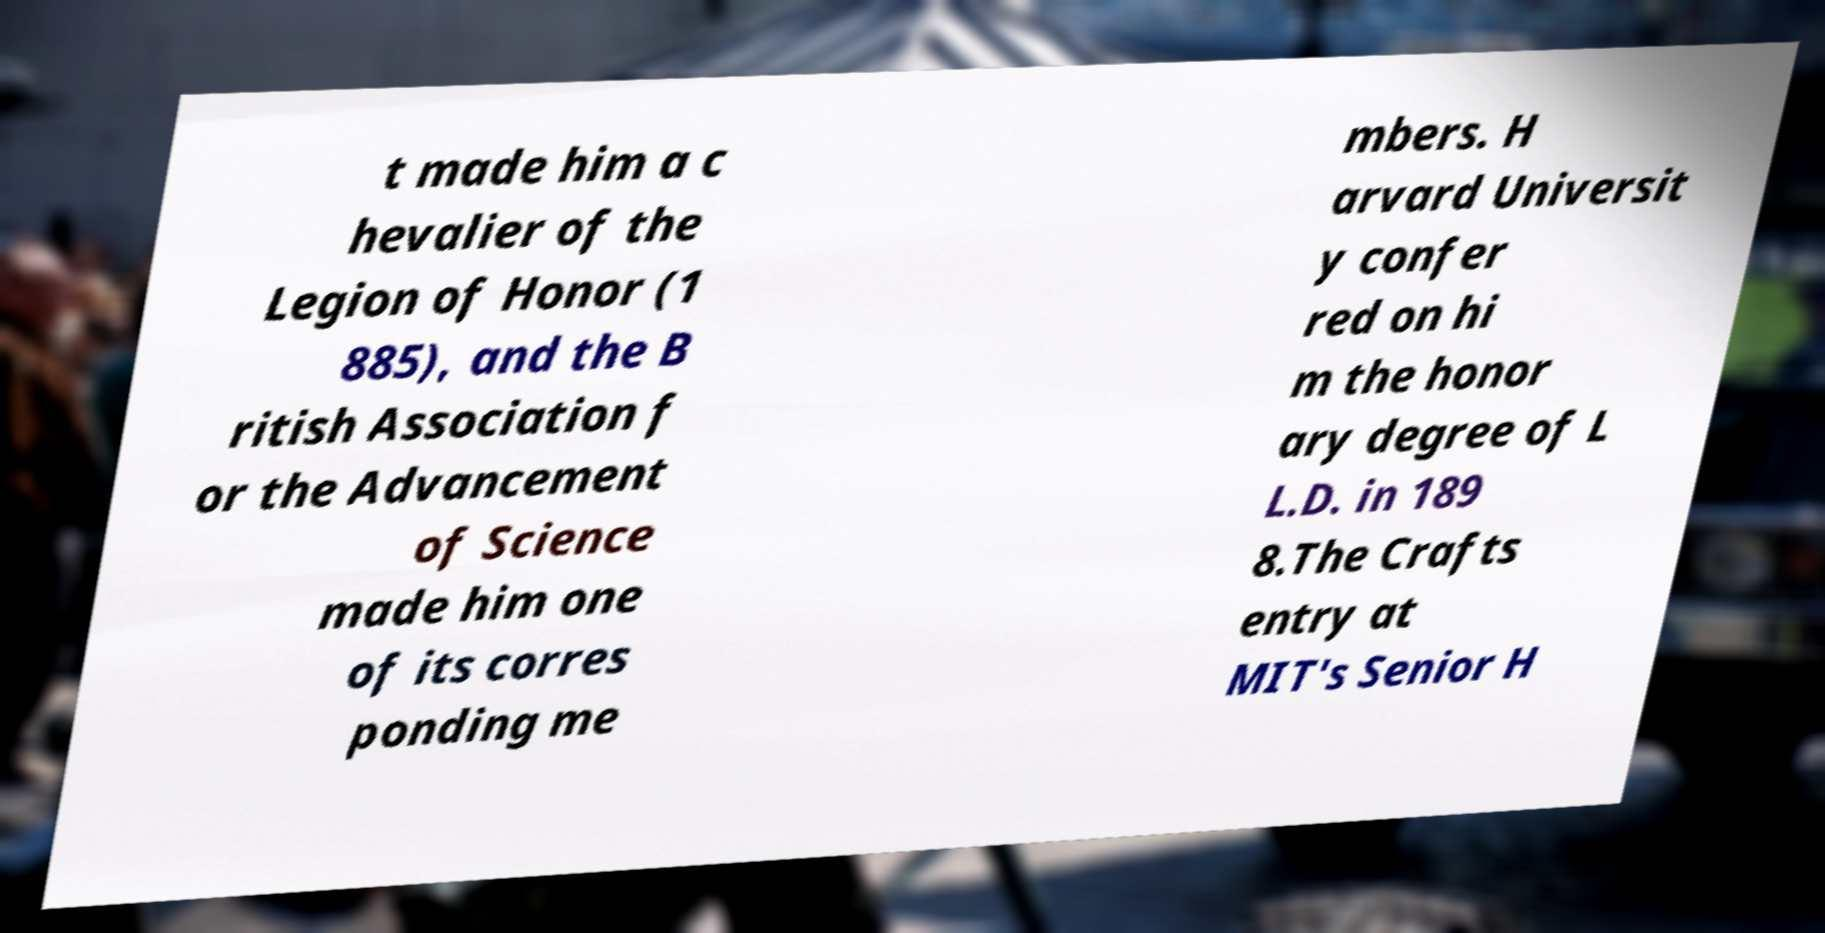Please identify and transcribe the text found in this image. t made him a c hevalier of the Legion of Honor (1 885), and the B ritish Association f or the Advancement of Science made him one of its corres ponding me mbers. H arvard Universit y confer red on hi m the honor ary degree of L L.D. in 189 8.The Crafts entry at MIT's Senior H 